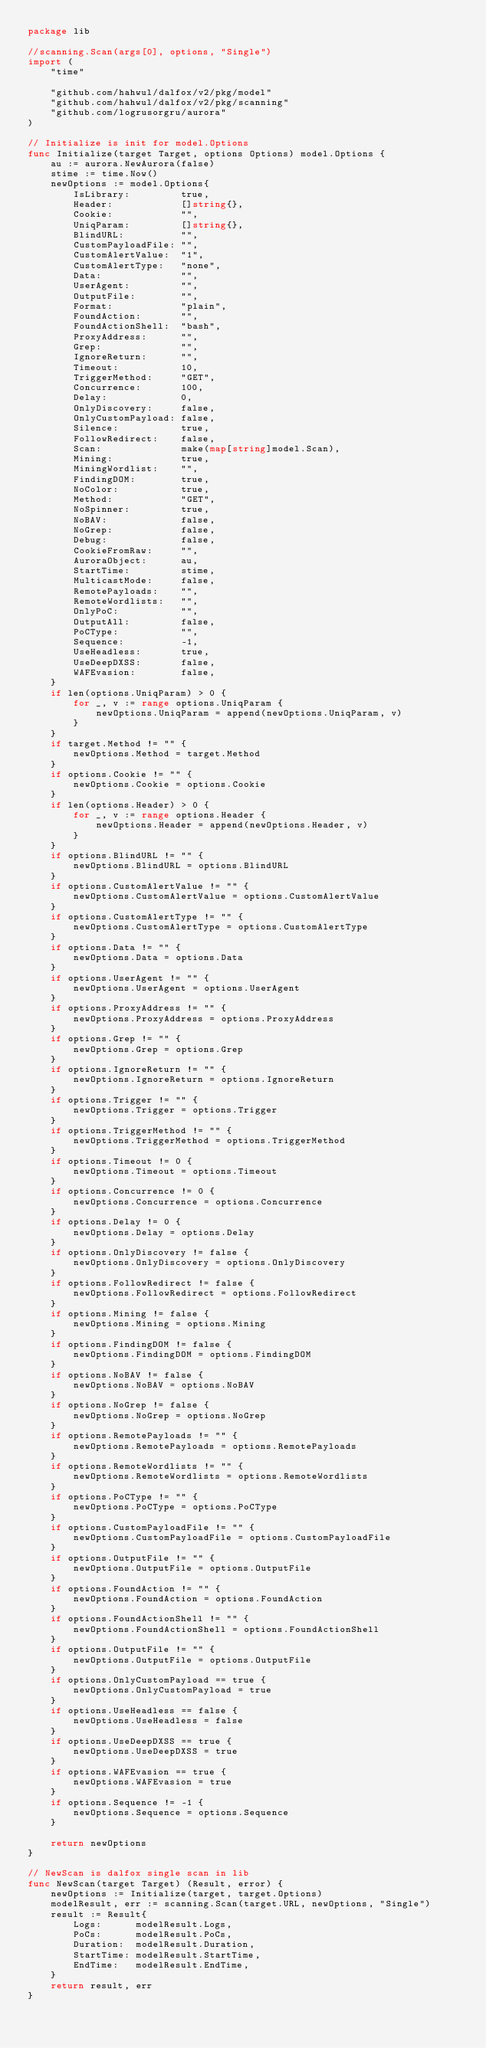<code> <loc_0><loc_0><loc_500><loc_500><_Go_>package lib

//scanning.Scan(args[0], options, "Single")
import (
	"time"

	"github.com/hahwul/dalfox/v2/pkg/model"
	"github.com/hahwul/dalfox/v2/pkg/scanning"
	"github.com/logrusorgru/aurora"
)

// Initialize is init for model.Options
func Initialize(target Target, options Options) model.Options {
	au := aurora.NewAurora(false)
	stime := time.Now()
	newOptions := model.Options{
		IsLibrary:         true,
		Header:            []string{},
		Cookie:            "",
		UniqParam:         []string{},
		BlindURL:          "",
		CustomPayloadFile: "",
		CustomAlertValue:  "1",
		CustomAlertType:   "none",
		Data:              "",
		UserAgent:         "",
		OutputFile:        "",
		Format:            "plain",
		FoundAction:       "",
		FoundActionShell:  "bash",
		ProxyAddress:      "",
		Grep:              "",
		IgnoreReturn:      "",
		Timeout:           10,
		TriggerMethod:     "GET",
		Concurrence:       100,
		Delay:             0,
		OnlyDiscovery:     false,
		OnlyCustomPayload: false,
		Silence:           true,
		FollowRedirect:    false,
		Scan:              make(map[string]model.Scan),
		Mining:            true,
		MiningWordlist:    "",
		FindingDOM:        true,
		NoColor:           true,
		Method:            "GET",
		NoSpinner:         true,
		NoBAV:             false,
		NoGrep:            false,
		Debug:             false,
		CookieFromRaw:     "",
		AuroraObject:      au,
		StartTime:         stime,
		MulticastMode:     false,
		RemotePayloads:    "",
		RemoteWordlists:   "",
		OnlyPoC:           "",
		OutputAll:         false,
		PoCType:           "",
		Sequence:          -1,
		UseHeadless:       true,
		UseDeepDXSS:       false,
		WAFEvasion:        false,
	}
	if len(options.UniqParam) > 0 {
		for _, v := range options.UniqParam {
			newOptions.UniqParam = append(newOptions.UniqParam, v)
		}
	}
	if target.Method != "" {
		newOptions.Method = target.Method
	}
	if options.Cookie != "" {
		newOptions.Cookie = options.Cookie
	}
	if len(options.Header) > 0 {
		for _, v := range options.Header {
			newOptions.Header = append(newOptions.Header, v)
		}
	}
	if options.BlindURL != "" {
		newOptions.BlindURL = options.BlindURL
	}
	if options.CustomAlertValue != "" {
		newOptions.CustomAlertValue = options.CustomAlertValue
	}
	if options.CustomAlertType != "" {
		newOptions.CustomAlertType = options.CustomAlertType
	}
	if options.Data != "" {
		newOptions.Data = options.Data
	}
	if options.UserAgent != "" {
		newOptions.UserAgent = options.UserAgent
	}
	if options.ProxyAddress != "" {
		newOptions.ProxyAddress = options.ProxyAddress
	}
	if options.Grep != "" {
		newOptions.Grep = options.Grep
	}
	if options.IgnoreReturn != "" {
		newOptions.IgnoreReturn = options.IgnoreReturn
	}
	if options.Trigger != "" {
		newOptions.Trigger = options.Trigger
	}
	if options.TriggerMethod != "" {
		newOptions.TriggerMethod = options.TriggerMethod
	}
	if options.Timeout != 0 {
		newOptions.Timeout = options.Timeout
	}
	if options.Concurrence != 0 {
		newOptions.Concurrence = options.Concurrence
	}
	if options.Delay != 0 {
		newOptions.Delay = options.Delay
	}
	if options.OnlyDiscovery != false {
		newOptions.OnlyDiscovery = options.OnlyDiscovery
	}
	if options.FollowRedirect != false {
		newOptions.FollowRedirect = options.FollowRedirect
	}
	if options.Mining != false {
		newOptions.Mining = options.Mining
	}
	if options.FindingDOM != false {
		newOptions.FindingDOM = options.FindingDOM
	}
	if options.NoBAV != false {
		newOptions.NoBAV = options.NoBAV
	}
	if options.NoGrep != false {
		newOptions.NoGrep = options.NoGrep
	}
	if options.RemotePayloads != "" {
		newOptions.RemotePayloads = options.RemotePayloads
	}
	if options.RemoteWordlists != "" {
		newOptions.RemoteWordlists = options.RemoteWordlists
	}
	if options.PoCType != "" {
		newOptions.PoCType = options.PoCType
	}
	if options.CustomPayloadFile != "" {
		newOptions.CustomPayloadFile = options.CustomPayloadFile
	}
	if options.OutputFile != "" {
		newOptions.OutputFile = options.OutputFile
	}
	if options.FoundAction != "" {
		newOptions.FoundAction = options.FoundAction
	}
	if options.FoundActionShell != "" {
		newOptions.FoundActionShell = options.FoundActionShell
	}
	if options.OutputFile != "" {
		newOptions.OutputFile = options.OutputFile
	}
	if options.OnlyCustomPayload == true {
		newOptions.OnlyCustomPayload = true
	}
	if options.UseHeadless == false {
		newOptions.UseHeadless = false
	}
	if options.UseDeepDXSS == true {
		newOptions.UseDeepDXSS = true
	}
	if options.WAFEvasion == true {
		newOptions.WAFEvasion = true
	}
	if options.Sequence != -1 {
		newOptions.Sequence = options.Sequence
	}

	return newOptions
}

// NewScan is dalfox single scan in lib
func NewScan(target Target) (Result, error) {
	newOptions := Initialize(target, target.Options)
	modelResult, err := scanning.Scan(target.URL, newOptions, "Single")
	result := Result{
		Logs:      modelResult.Logs,
		PoCs:      modelResult.PoCs,
		Duration:  modelResult.Duration,
		StartTime: modelResult.StartTime,
		EndTime:   modelResult.EndTime,
	}
	return result, err
}
</code> 